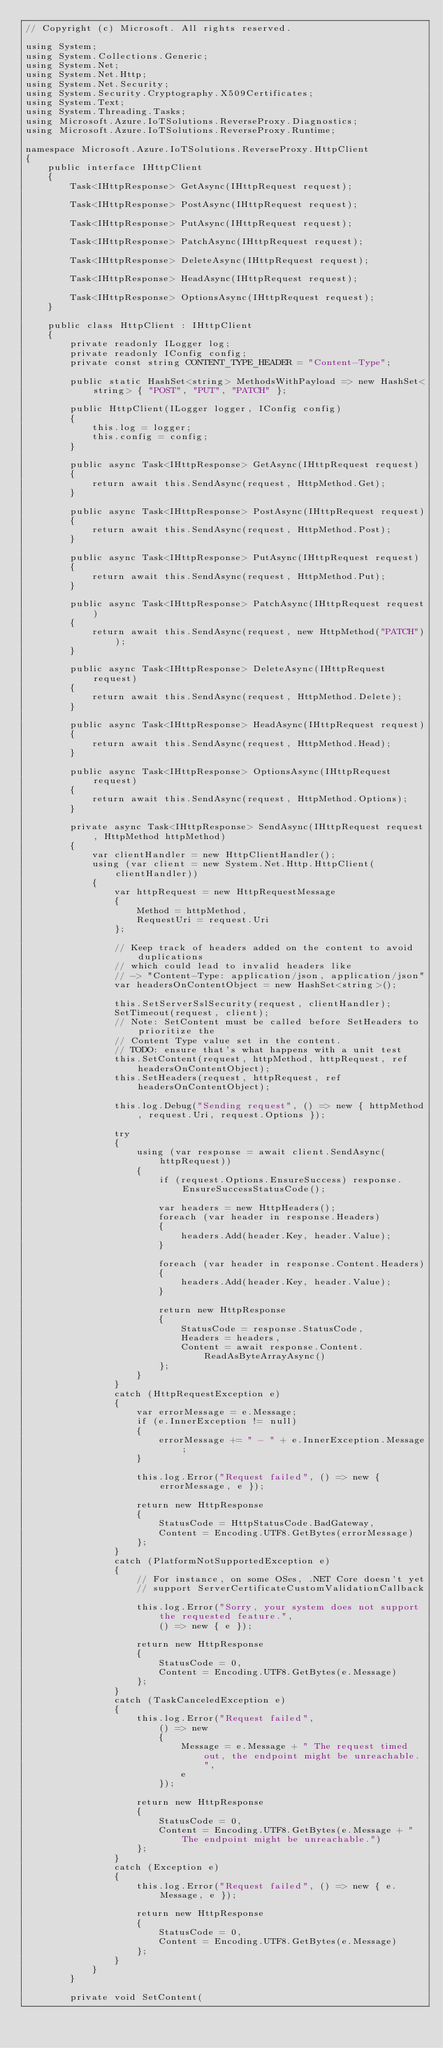Convert code to text. <code><loc_0><loc_0><loc_500><loc_500><_C#_>// Copyright (c) Microsoft. All rights reserved.

using System;
using System.Collections.Generic;
using System.Net;
using System.Net.Http;
using System.Net.Security;
using System.Security.Cryptography.X509Certificates;
using System.Text;
using System.Threading.Tasks;
using Microsoft.Azure.IoTSolutions.ReverseProxy.Diagnostics;
using Microsoft.Azure.IoTSolutions.ReverseProxy.Runtime;

namespace Microsoft.Azure.IoTSolutions.ReverseProxy.HttpClient
{
    public interface IHttpClient
    {
        Task<IHttpResponse> GetAsync(IHttpRequest request);

        Task<IHttpResponse> PostAsync(IHttpRequest request);

        Task<IHttpResponse> PutAsync(IHttpRequest request);

        Task<IHttpResponse> PatchAsync(IHttpRequest request);

        Task<IHttpResponse> DeleteAsync(IHttpRequest request);

        Task<IHttpResponse> HeadAsync(IHttpRequest request);

        Task<IHttpResponse> OptionsAsync(IHttpRequest request);
    }

    public class HttpClient : IHttpClient
    {
        private readonly ILogger log;
        private readonly IConfig config;
        private const string CONTENT_TYPE_HEADER = "Content-Type";

        public static HashSet<string> MethodsWithPayload => new HashSet<string> { "POST", "PUT", "PATCH" };

        public HttpClient(ILogger logger, IConfig config)
        {
            this.log = logger;
            this.config = config;
        }

        public async Task<IHttpResponse> GetAsync(IHttpRequest request)
        {
            return await this.SendAsync(request, HttpMethod.Get);
        }

        public async Task<IHttpResponse> PostAsync(IHttpRequest request)
        {
            return await this.SendAsync(request, HttpMethod.Post);
        }

        public async Task<IHttpResponse> PutAsync(IHttpRequest request)
        {
            return await this.SendAsync(request, HttpMethod.Put);
        }

        public async Task<IHttpResponse> PatchAsync(IHttpRequest request)
        {
            return await this.SendAsync(request, new HttpMethod("PATCH"));
        }

        public async Task<IHttpResponse> DeleteAsync(IHttpRequest request)
        {
            return await this.SendAsync(request, HttpMethod.Delete);
        }

        public async Task<IHttpResponse> HeadAsync(IHttpRequest request)
        {
            return await this.SendAsync(request, HttpMethod.Head);
        }

        public async Task<IHttpResponse> OptionsAsync(IHttpRequest request)
        {
            return await this.SendAsync(request, HttpMethod.Options);
        }

        private async Task<IHttpResponse> SendAsync(IHttpRequest request, HttpMethod httpMethod)
        {
            var clientHandler = new HttpClientHandler();
            using (var client = new System.Net.Http.HttpClient(clientHandler))
            {
                var httpRequest = new HttpRequestMessage
                {
                    Method = httpMethod,
                    RequestUri = request.Uri
                };

                // Keep track of headers added on the content to avoid duplications
                // which could lead to invalid headers like
                // -> "Content-Type: application/json, application/json"
                var headersOnContentObject = new HashSet<string>();

                this.SetServerSslSecurity(request, clientHandler);
                SetTimeout(request, client);
                // Note: SetContent must be called before SetHeaders to prioritize the
                // Content Type value set in the content.
                // TODO: ensure that's what happens with a unit test
                this.SetContent(request, httpMethod, httpRequest, ref headersOnContentObject);
                this.SetHeaders(request, httpRequest, ref headersOnContentObject);

                this.log.Debug("Sending request", () => new { httpMethod, request.Uri, request.Options });

                try
                {
                    using (var response = await client.SendAsync(httpRequest))
                    {
                        if (request.Options.EnsureSuccess) response.EnsureSuccessStatusCode();

                        var headers = new HttpHeaders();
                        foreach (var header in response.Headers)
                        {
                            headers.Add(header.Key, header.Value);
                        }

                        foreach (var header in response.Content.Headers)
                        {
                            headers.Add(header.Key, header.Value);
                        }

                        return new HttpResponse
                        {
                            StatusCode = response.StatusCode,
                            Headers = headers,
                            Content = await response.Content.ReadAsByteArrayAsync()
                        };
                    }
                }
                catch (HttpRequestException e)
                {
                    var errorMessage = e.Message;
                    if (e.InnerException != null)
                    {
                        errorMessage += " - " + e.InnerException.Message;
                    }

                    this.log.Error("Request failed", () => new { errorMessage, e });

                    return new HttpResponse
                    {
                        StatusCode = HttpStatusCode.BadGateway,
                        Content = Encoding.UTF8.GetBytes(errorMessage)
                    };
                }
                catch (PlatformNotSupportedException e)
                {
                    // For instance, on some OSes, .NET Core doesn't yet
                    // support ServerCertificateCustomValidationCallback

                    this.log.Error("Sorry, your system does not support the requested feature.",
                        () => new { e });

                    return new HttpResponse
                    {
                        StatusCode = 0,
                        Content = Encoding.UTF8.GetBytes(e.Message)
                    };
                }
                catch (TaskCanceledException e)
                {
                    this.log.Error("Request failed",
                        () => new
                        {
                            Message = e.Message + " The request timed out, the endpoint might be unreachable.",
                            e
                        });

                    return new HttpResponse
                    {
                        StatusCode = 0,
                        Content = Encoding.UTF8.GetBytes(e.Message + " The endpoint might be unreachable.")
                    };
                }
                catch (Exception e)
                {
                    this.log.Error("Request failed", () => new { e.Message, e });

                    return new HttpResponse
                    {
                        StatusCode = 0,
                        Content = Encoding.UTF8.GetBytes(e.Message)
                    };
                }
            }
        }

        private void SetContent(</code> 